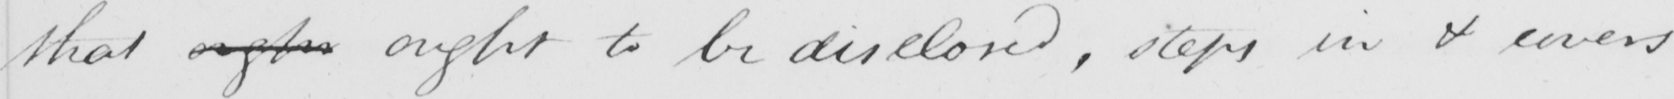What is written in this line of handwriting? that oughr ought to be disclosed , steps in & covers 